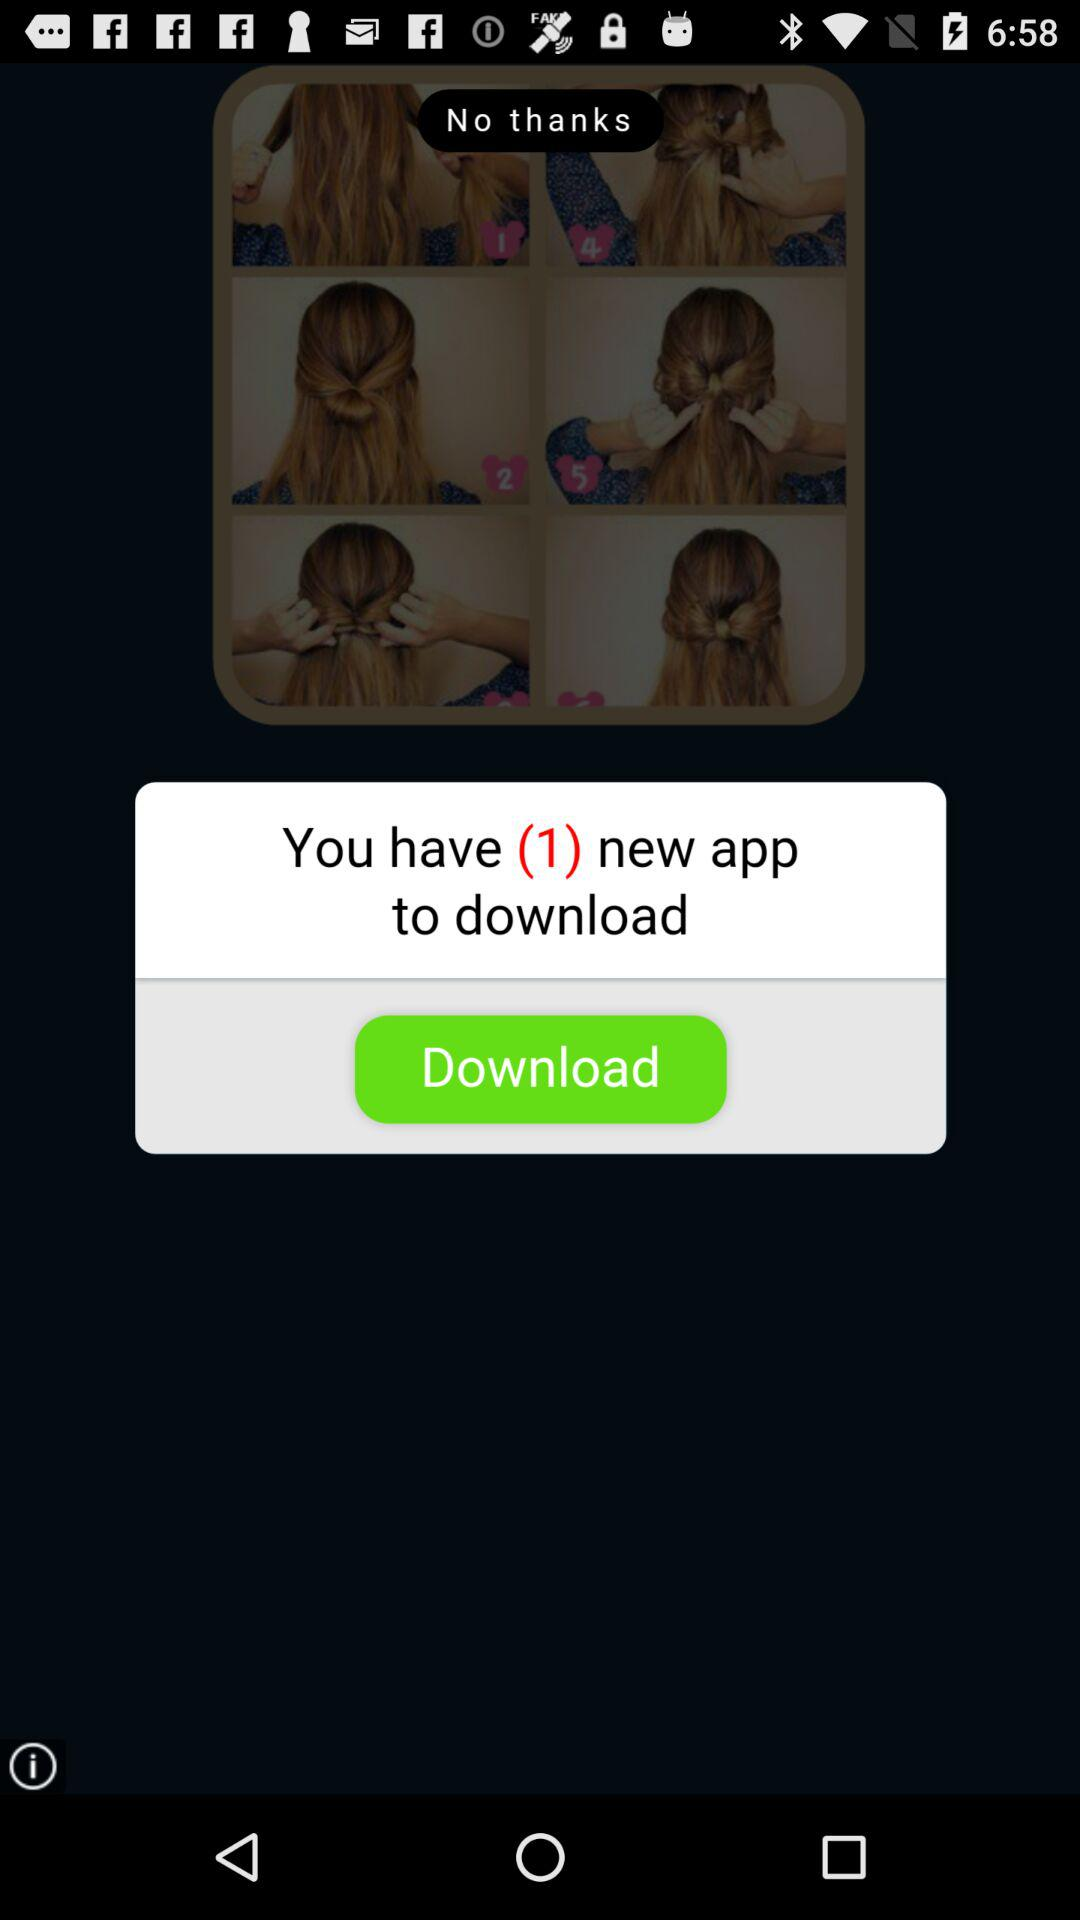How many new apps are available to download? There is 1 new app to download. 